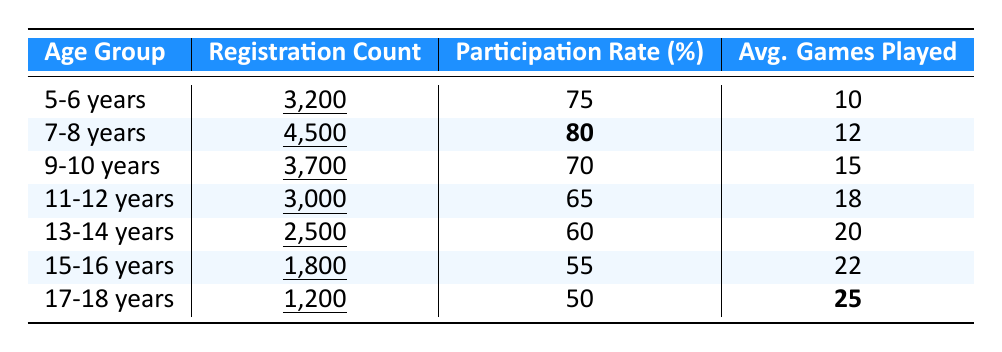What is the participation rate for the age group 7-8 years? From the table, the participation rate for the age group 7-8 years is directly listed as 80%.
Answer: 80% How many youth registered for baseball in the 15-16 years age group? The table shows that the registration count for the 15-16 years age group is 1,800.
Answer: 1,800 What is the average number of games played by the 11-12 years age group? The average games played by the 11-12 years age group is explicitly mentioned in the table as 18.
Answer: 18 Which age group has the highest registration count? By comparing the registration counts across all age groups in the table, the 7-8 years age group has the highest count at 4,500.
Answer: 7-8 years What is the difference in participation rates between the 9-10 years and the 13-14 years age groups? The participation rate for 9-10 years is 70% and for 13-14 years is 60%. The difference is 70% - 60% = 10%.
Answer: 10% What percentage of youth in the 17-18 years age group played more than 20 games? The average games played for the 17-18 years age group is 25, which is greater than 20. So, yes, every player in this group played more than 20 games.
Answer: Yes What is the total number of registrations for all age groups combined? To find the total, we add the registration counts: 3200 + 4500 + 3700 + 3000 + 2500 + 1800 + 1200 = 19,900.
Answer: 19,900 Which age group played the most average games? The table indicates the average games played for the 17-18 years age group is 25, which is the highest among all age groups.
Answer: 17-18 years What is the average registration count across all age groups? To calculate the average registration count, we sum all the registration counts (3200 + 4500 + 3700 + 3000 + 2500 + 1800 + 1200 = 19,900) and divide by the number of age groups (7): 19,900 / 7 = 2,843.
Answer: 2,843 Is there an age group that has a participation rate of exactly 75%? Yes, the age group 5-6 years has a participation rate of exactly 75% as shown in the table.
Answer: Yes Which age group experienced a decrease in participation rate compared to the previous age group? By analyzing the participation rates, 11-12 years (65%) has a lower rate compared to 9-10 years (70%), and 13-14 years (60%) is lower than 11-12 years. So, both 11-12 and 13-14 years experienced a decrease.
Answer: 11-12 and 13-14 years 